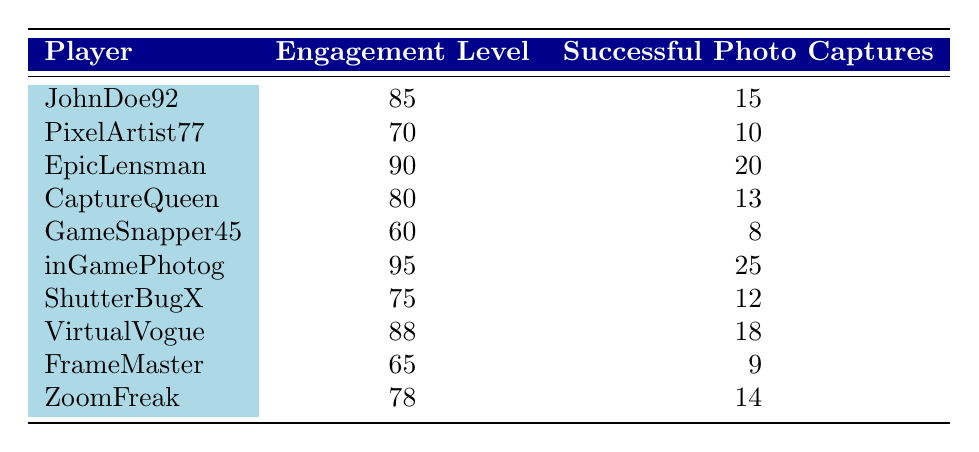What is the engagement level of inGamePhotog? According to the table, the engagement level for inGamePhotog is listed directly alongside that player's name, which shows an engagement level of 95.
Answer: 95 Which player had the lowest number of successful photo captures? By reviewing the "Successful Photo Captures" column, GameSnapper45 has the lowest count, with only 8 successful captures.
Answer: GameSnapper45 What is the average engagement level of all players? To find the average engagement level, we add the engagement levels together: (85 + 70 + 90 + 80 + 60 + 95 + 75 + 88 + 65 + 78) =  866. There are 10 players, so the average is 866 / 10 = 86.6.
Answer: 86.6 Is VirtualVogue's successful photo captures count greater than CaptureQueen's? The number of successful captures for VirtualVogue is 18, while for CaptureQueen it is 13. Since 18 is greater than 13, the answer is yes.
Answer: Yes How many players have an engagement level greater than 80? By counting the players with engagement levels greater than 80 in the table, we find: JohnDoe92 (85), EpicLensman (90), inGamePhotog (95), VirtualVogue (88), totaling 4 players.
Answer: 4 What is the difference between the highest and the lowest successful photo captures? The highest successful captures are from inGamePhotog with 25, and the lowest are from GameSnapper45 with 8. The difference is 25 - 8 = 17.
Answer: 17 Do any players have both engagement levels over 90 and successful captures over 20? Evaluating inGamePhotog who has 95 engagement and 25 captures does meet both conditions. Therefore, the answer is yes.
Answer: Yes What is the median number of successful photo captures among all players? Arranging the successful photo captures in ascending order gives us: 8, 9, 10, 12, 13, 14, 15, 18, 20, 25. Since there are 10 values, the median is the average of the 5th (13) and 6th (14) values: (13 + 14) / 2 = 13.5.
Answer: 13.5 Which player has a successful photo capture count that is exactly double the number of captures of FrameMaster? FrameMaster has 9 successful captures, and the only player with 18 captures is VirtualVogue, which is exactly double. So the answer is VirtualVogue.
Answer: VirtualVogue 